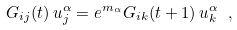Convert formula to latex. <formula><loc_0><loc_0><loc_500><loc_500>G _ { i j } ( t ) \, u ^ { \alpha } _ { j } = e ^ { m _ { \alpha } } G _ { i k } ( t + 1 ) \, u ^ { \alpha } _ { k } \ ,</formula> 